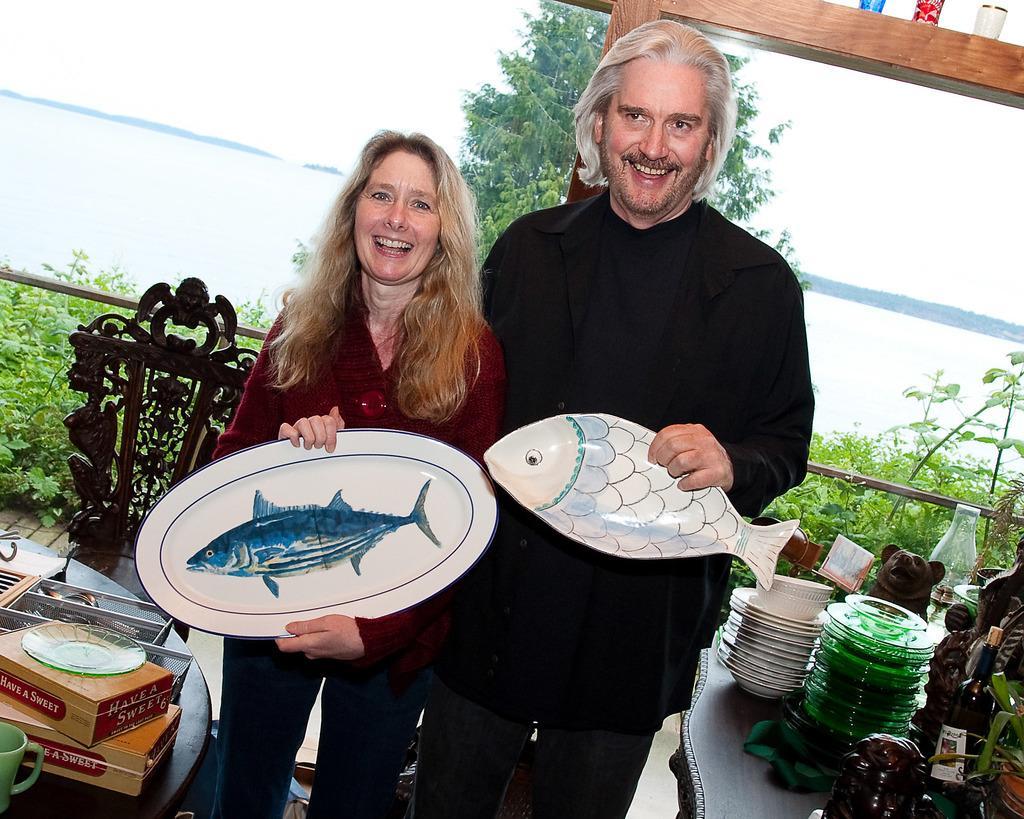How would you summarize this image in a sentence or two? In this image, we can see a man and a woman standing and they are holding two objects in their hands. We can see tables, there are some plates and other objects on the tables. We can see a chair and there are some plants. 